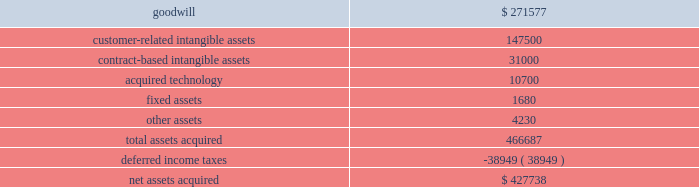Cash and a commitment to fund the capital needs of the business until such time as its cumulative funding is equal to funding that we have provided from inception through the effective date of the transaction .
The transaction created a new joint venture which does business as comercia global payments brazil .
As a result of the transaction , we deconsolidated global payments brazil , and we apply the equity method of accounting to our retained interest in comercia global payments brazil .
We recorded a gain on the transaction of $ 2.1 million which is included in interest and other income in the consolidated statement of income for the fiscal year ended may 31 , 2014 .
The results of the brazil operation from inception until the restructuring into a joint venture on september 30 , 2013 were not material to our consolidated results of operations , and the assets and liabilities that we derecognized were not material to our consolidated balance sheet .
American express portfolio on october 24 , 2013 , we acquired a merchant portfolio in the czech republic from american express limited for $ 1.9 million .
The acquired assets have been classified as customer-related intangible assets and contract-based intangible assets with estimated amortization periods of 10 years .
Paypros on march 4 , 2014 , we completed the acquisition of 100% ( 100 % ) of the outstanding stock of payment processing , inc .
( 201cpaypros 201d ) for $ 420.0 million in cash plus $ 7.7 million in cash for working capital , subject to adjustment based on a final determination of working capital .
We funded the acquisition with a combination of cash on hand and proceeds from our new term loan .
Paypros , based in california , is a provider of fully-integrated payment solutions for small-to-medium sized merchants in the united states .
Paypros delivers its products and services through a network of technology-based enterprise software partners to vertical markets that are complementary to the markets served by accelerated payment technologies ( 201capt 201d ) , which we acquired in october 2012 .
We acquired paypros to expand our direct distribution capabilities in the united states and to further enhance our existing integrated solutions offerings .
This acquisition was recorded as a business combination , and the purchase price was allocated to the assets acquired and liabilities assumed based on their estimated fair values .
Due to the timing of this transaction , the allocation of the purchase price is preliminary pending final valuation of intangible assets and deferred income taxes as well as resolution of the working capital settlement discussed above .
The purchase price of paypros was determined by analyzing the historical and prospective financial statements .
Acquisition costs associated with this purchase were not material .
The table summarizes the preliminary purchase price allocation ( in thousands ) : .
The preliminary purchase price allocation resulted in goodwill , included in the north america merchant services segment , of $ 271.6 million .
Such goodwill is attributable primarily to synergies with the services offered and markets served by paypros .
The goodwill associated with the acquisition is not deductible for tax purposes .
The customer-related intangible assets and the contract-based intangible assets have an estimated amortization period of 13 years .
The acquired technology has an estimated amortization period of 7 years. .
What percent of assets for the acquisition of paypros was deductible for taxes? 
Rationale: to find the percentage of assets that are tax deductible one will nee to added all the intangible assets and technology acquisitions . then they will divide that answer by the total amount of assets .
Computations: ((147500 + (10700 + 31000)) / 466687)
Answer: 0.40541. 